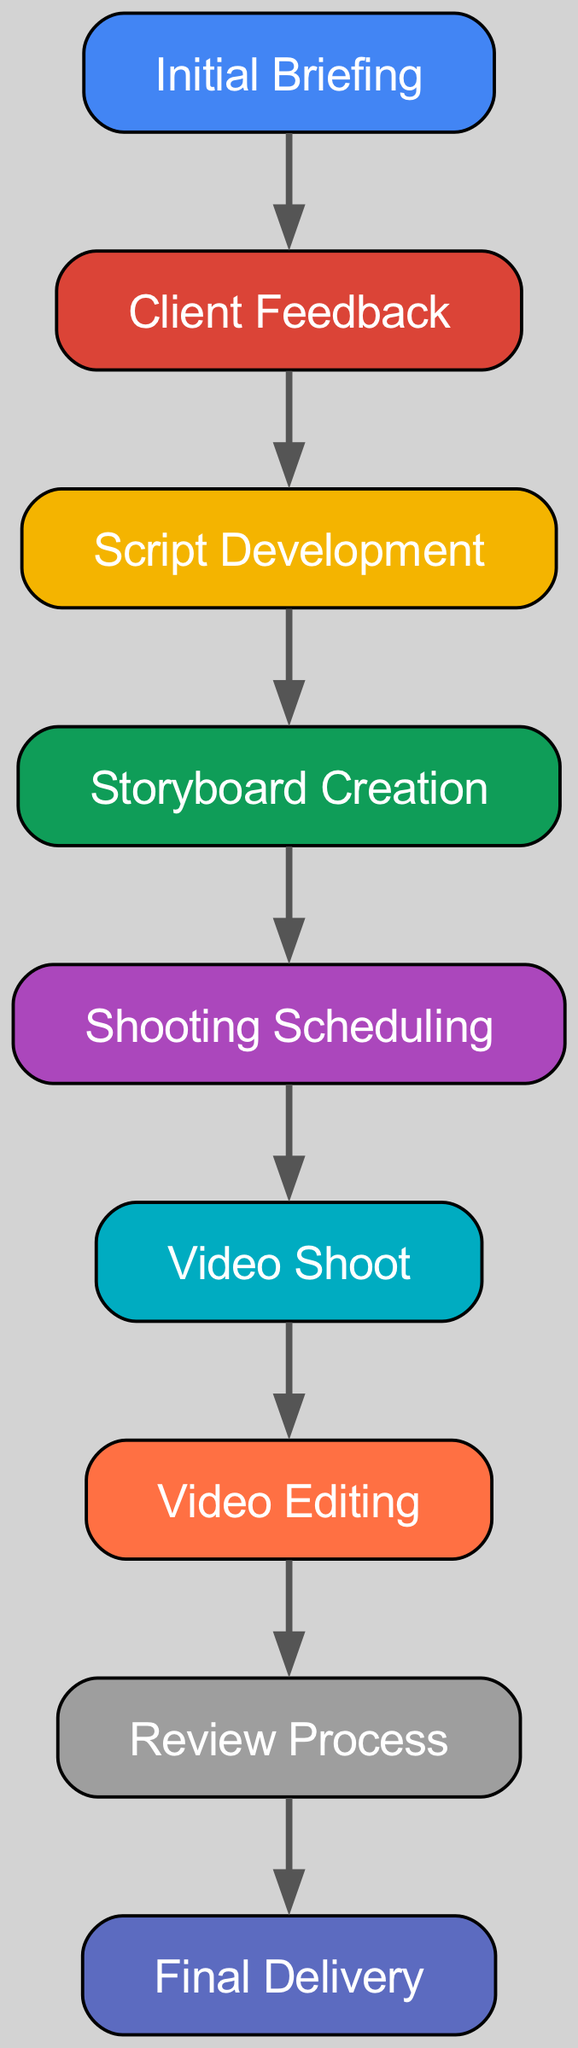What is the starting point of the workflow? The starting point of the workflow is represented by the node "Initial Briefing," which serves as the first stage of the process according to the directed graph.
Answer: Initial Briefing How many nodes are in the diagram? By counting the unique points that represent different stages in the workflow, I identified 9 nodes in total in the directed graph.
Answer: 9 What follows the Client Feedback stage? The directed edge leading out of the "Client Feedback" node points to "Script Development," indicating that this is the next stage after client feedback in the workflow.
Answer: Script Development Which node comes before Video Editing? Tracing the directed edges in reverse from the node "Video Editing," the node "Review Process" directs to it, indicating that the review process is the immediate preceding stage.
Answer: Review Process How many edges are shown in the diagram? By examining the connections between the various nodes in the directed graph, I found that there are 8 edges representing the flow between different stages in the workflow.
Answer: 8 What is the final delivery point in this workflow? The last node in the directed graph is "Final Delivery," which clearly indicates that this is the conclusive stage where the project is delivered to the client.
Answer: Final Delivery Which two nodes are directly connected by an edge to Script Development? The node "Client Feedback" points to "Script Development" as the previous stage, while "Storyboard Creation" points back to it as the next stage, indicating a directional flow.
Answer: Client Feedback and Storyboard Creation What is the relationship between Storyboard Creation and Shooting Scheduling? The directed edge clearly shows that "Storyboard Creation" directly leads to "Shooting Scheduling," indicating that the completion of the storyboard directly influences the scheduling of shooting.
Answer: Directly leads to What node indicates a step before the final stage? The node "Review Process" precedes the final delivery in the workflow as denoted by the directed edge flowing into "Final Delivery."
Answer: Review Process 